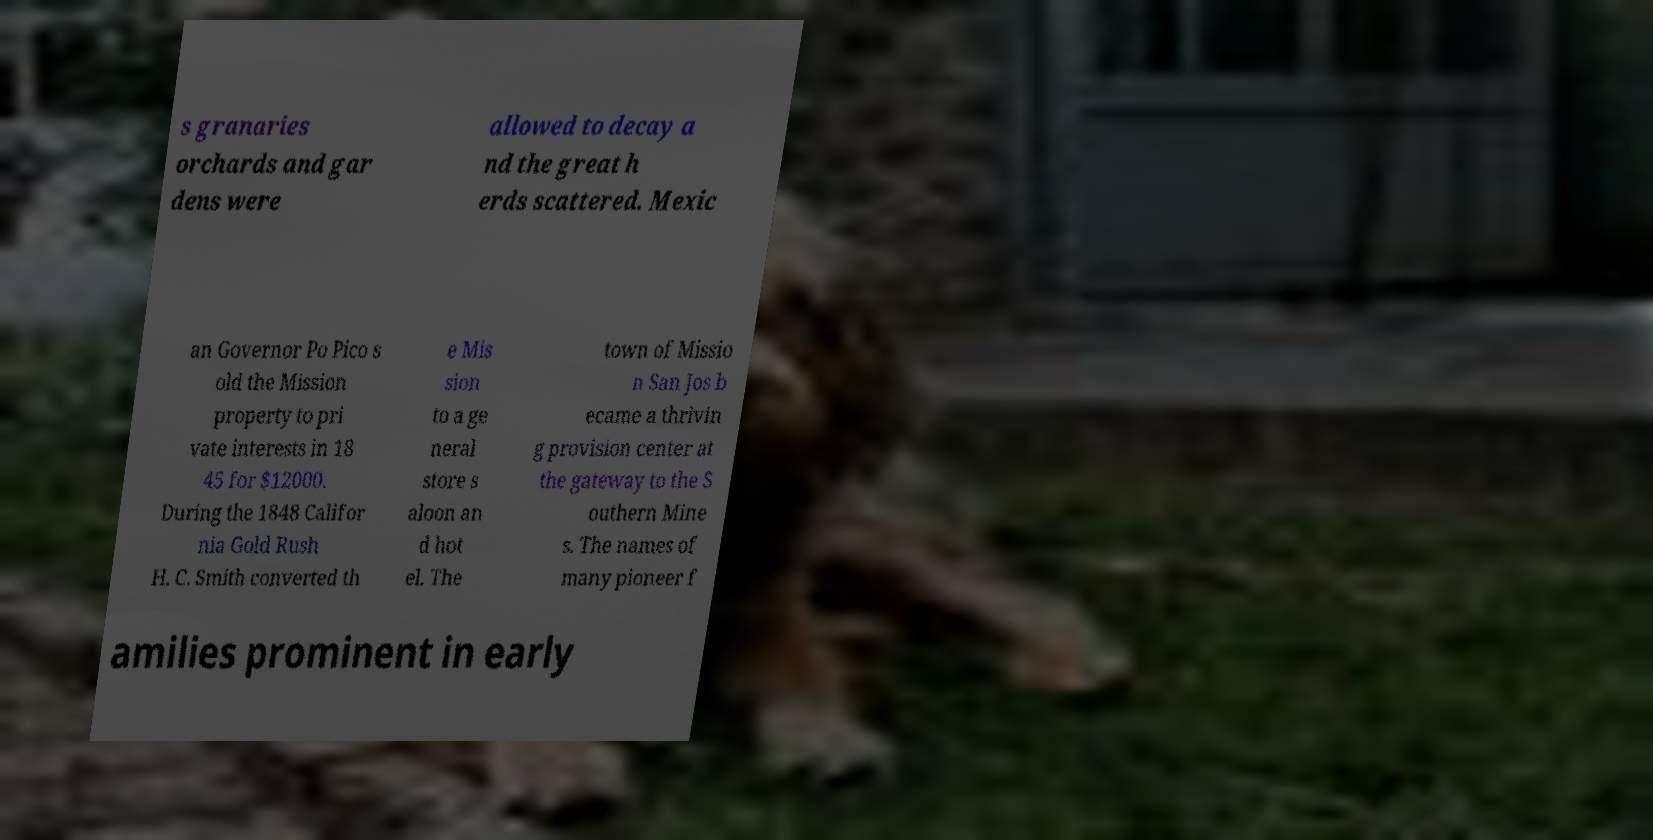For documentation purposes, I need the text within this image transcribed. Could you provide that? s granaries orchards and gar dens were allowed to decay a nd the great h erds scattered. Mexic an Governor Po Pico s old the Mission property to pri vate interests in 18 45 for $12000. During the 1848 Califor nia Gold Rush H. C. Smith converted th e Mis sion to a ge neral store s aloon an d hot el. The town of Missio n San Jos b ecame a thrivin g provision center at the gateway to the S outhern Mine s. The names of many pioneer f amilies prominent in early 